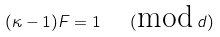<formula> <loc_0><loc_0><loc_500><loc_500>( \kappa - 1 ) F = 1 \quad ( \text {mod} \, d )</formula> 